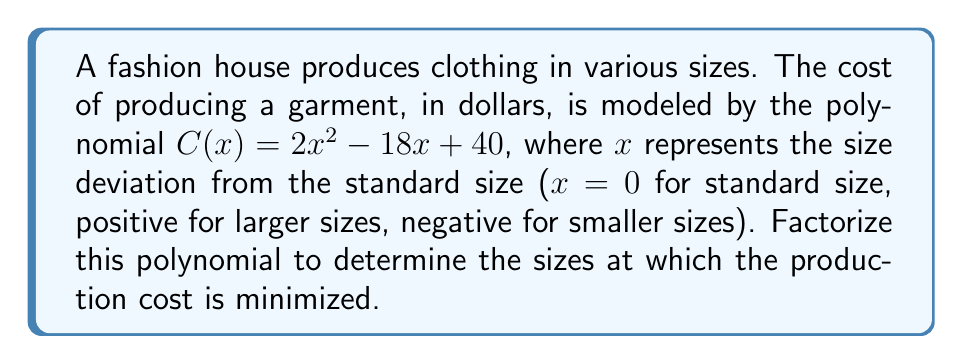Can you answer this question? To factorize the polynomial $C(x) = 2x^2 - 18x + 40$, we'll follow these steps:

1) First, we identify that this is a quadratic equation in the form $ax^2 + bx + c$, where:
   $a = 2$, $b = -18$, and $c = 40$

2) To factorize, we'll use the quadratic formula to find the roots:
   $x = \frac{-b \pm \sqrt{b^2 - 4ac}}{2a}$

3) Let's calculate the discriminant $b^2 - 4ac$:
   $(-18)^2 - 4(2)(40) = 324 - 320 = 4$

4) Now we can solve for x:
   $x = \frac{18 \pm \sqrt{4}}{2(2)} = \frac{18 \pm 2}{4}$

5) This gives us two solutions:
   $x_1 = \frac{18 + 2}{4} = \frac{20}{4} = 5$
   $x_2 = \frac{18 - 2}{4} = \frac{16}{4} = 4$

6) Therefore, we can factorize the polynomial as:
   $C(x) = 2(x - 5)(x - 4)$

7) In the context of the fashion industry, this means the production cost is minimized when the size deviation is between 4 and 5 units from the standard size. This could indicate that the most cost-effective sizes to produce are slightly larger than the standard size, which might be an interesting insight for a fashion industry insider.
Answer: $C(x) = 2(x - 5)(x - 4)$ 